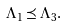Convert formula to latex. <formula><loc_0><loc_0><loc_500><loc_500>\Lambda _ { 1 } \preceq \Lambda _ { 3 } .</formula> 